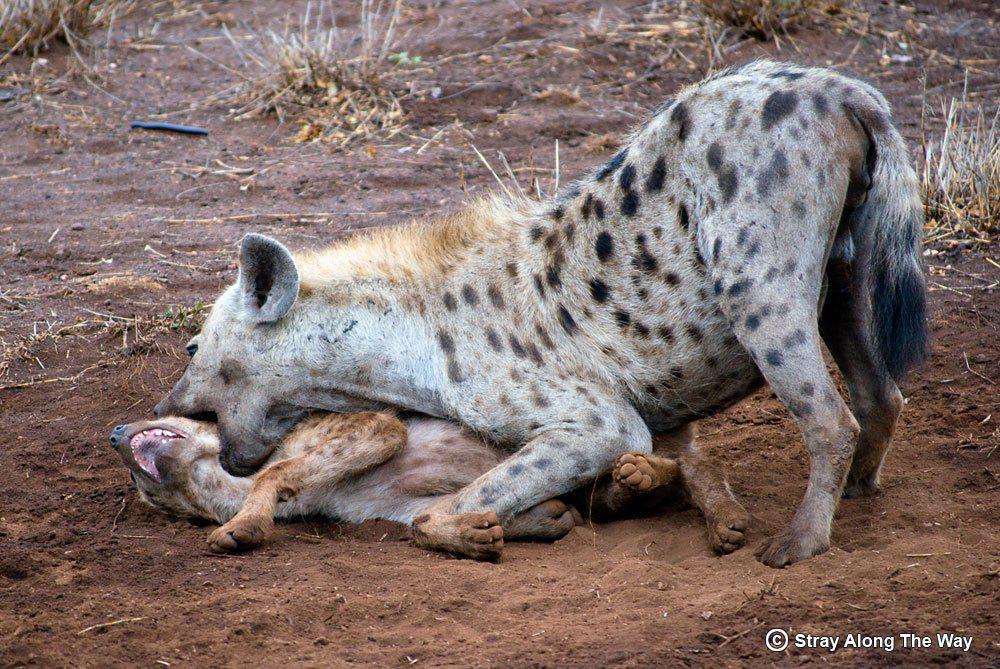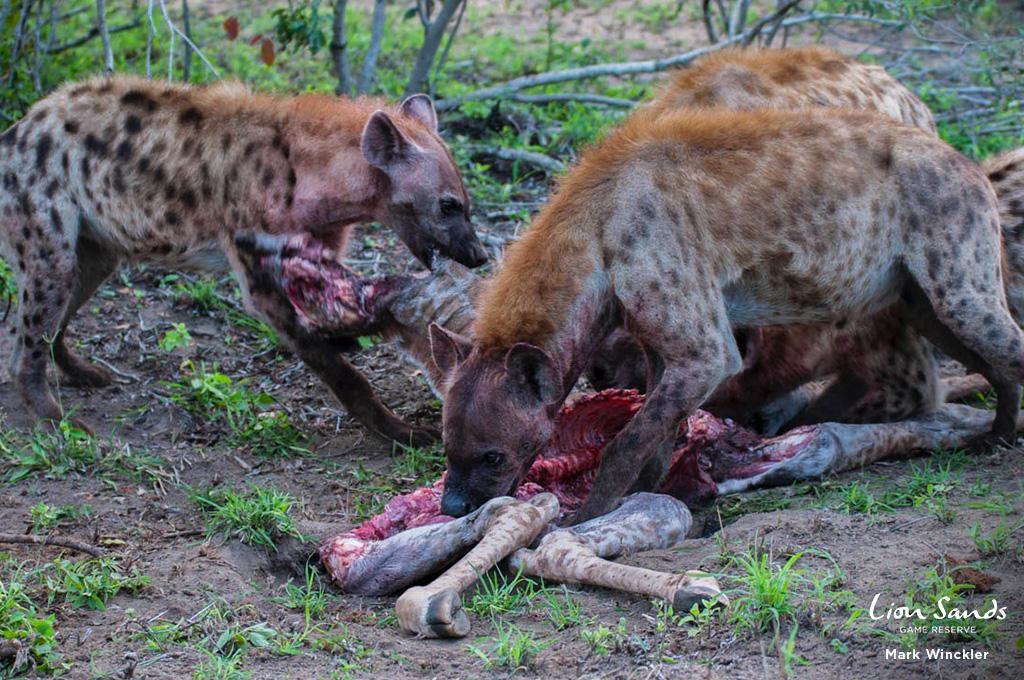The first image is the image on the left, the second image is the image on the right. Evaluate the accuracy of this statement regarding the images: "none of the hyenas are eating, at the moment.". Is it true? Answer yes or no. No. The first image is the image on the left, the second image is the image on the right. Examine the images to the left and right. Is the description "Neither image shows a carcass near a hyena, and one image shows exactly two hyenas, with one behind the other." accurate? Answer yes or no. No. 